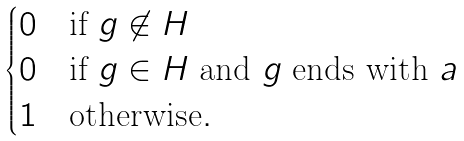<formula> <loc_0><loc_0><loc_500><loc_500>\begin{cases} 0 & \text {if } g \not \in H \\ 0 & \text {if } g \in H \text { and } g \text { ends with } a \\ 1 & \text {otherwise} . \end{cases}</formula> 